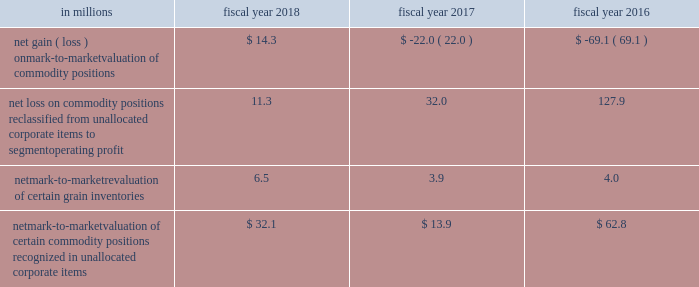Unallocated corporate items for fiscal 2018 , 2017 and 2016 included: .
Net mark-to-market valuation of certain commodity positions recognized in unallocated corporate items $ 32.1 $ 13.9 $ 62.8 as of may 27 , 2018 , the net notional value of commodity derivatives was $ 238.8 million , of which $ 147.9 million related to agricultural inputs and $ 90.9 million related to energy inputs .
These contracts relate to inputs that generally will be utilized within the next 12 months .
Interest rate risk we are exposed to interest rate volatility with regard to future issuances of fixed-rate debt , and existing and future issuances of floating-rate debt .
Primary exposures include u.s .
Treasury rates , libor , euribor , and commercial paper rates in the united states and europe .
We use interest rate swaps , forward-starting interest rate swaps , and treasury locks to hedge our exposure to interest rate changes , to reduce the volatility of our financing costs , and to achieve a desired proportion of fixed rate versus floating-rate debt , based on current and projected market conditions .
Generally under these swaps , we agree with a counterparty to exchange the difference between fixed-rate and floating-rate interest amounts based on an agreed upon notional principal amount .
Floating interest rate exposures 2014 floating-to-fixed interest rate swaps are accounted for as cash flow hedges , as are all hedges of forecasted issuances of debt .
Effectiveness is assessed based on either the perfectly effective hypothetical derivative method or changes in the present value of interest payments on the underlying debt .
Effective gains and losses deferred to aoci are reclassified into earnings over the life of the associated debt .
Ineffective gains and losses are recorded as net interest .
The amount of hedge ineffectiveness was a $ 2.6 million loss in fiscal 2018 , and less than $ 1 million in fiscal 2017 and 2016 .
Fixed interest rate exposures 2014 fixed-to-floating interest rate swaps are accounted for as fair value hedges with effectiveness assessed based on changes in the fair value of the underlying debt and derivatives , using incremental borrowing rates currently available on loans with similar terms and maturities .
Ineffective gains and losses on these derivatives and the underlying hedged items are recorded as net interest .
The amount of hedge ineffectiveness was a $ 3.4 million loss in fiscal 2018 , a $ 4.3 million gain in fiscal 2017 , and less than $ 1 million in fiscal 2016 .
In advance of planned debt financing related to the acquisition of blue buffalo , we entered into $ 3800.0 million of treasury locks due april 19 , 2018 , with an average fixed rate of 2.9 percent , of which $ 2300.0 million were entered into in the third quarter of fiscal 2018 and $ 1500.0 million were entered into in the fourth quarter of fiscal 2018 .
All of these treasury locks were cash settled for $ 43.9 million during the fourth quarter of fiscal 2018 , concurrent with the issuance of our $ 850.0 million 5.5-year fixed-rate notes , $ 800.0 million 7-year fixed- rate notes , $ 1400.0 million 10-year fixed-rate notes , $ 500.0 million 20-year fixed-rate notes , and $ 650.0 million 30-year fixed-rate notes .
In advance of planned debt financing , in fiscal 2018 , we entered into $ 500.0 million of treasury locks due october 15 , 2017 with an average fixed rate of 1.8 percent .
All of these treasury locks were cash settled for $ 3.7 million during the second quarter of fiscal 2018 , concurrent with the issuance of our $ 500.0 million 5-year fixed-rate notes. .
What is the net change of netmark-to-marketvaluation of certain commodity positions from 2017 to 2018? 
Computations: (32.1 - 13.9)
Answer: 18.2. 